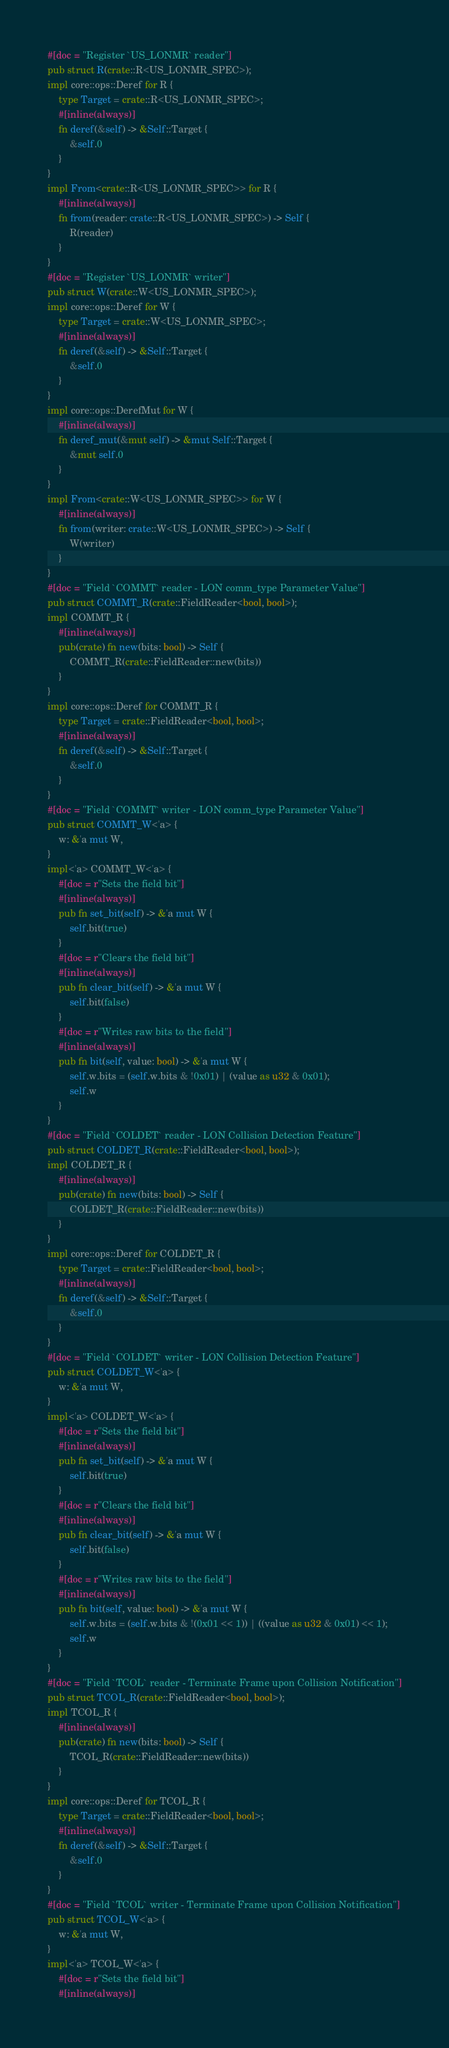Convert code to text. <code><loc_0><loc_0><loc_500><loc_500><_Rust_>#[doc = "Register `US_LONMR` reader"]
pub struct R(crate::R<US_LONMR_SPEC>);
impl core::ops::Deref for R {
    type Target = crate::R<US_LONMR_SPEC>;
    #[inline(always)]
    fn deref(&self) -> &Self::Target {
        &self.0
    }
}
impl From<crate::R<US_LONMR_SPEC>> for R {
    #[inline(always)]
    fn from(reader: crate::R<US_LONMR_SPEC>) -> Self {
        R(reader)
    }
}
#[doc = "Register `US_LONMR` writer"]
pub struct W(crate::W<US_LONMR_SPEC>);
impl core::ops::Deref for W {
    type Target = crate::W<US_LONMR_SPEC>;
    #[inline(always)]
    fn deref(&self) -> &Self::Target {
        &self.0
    }
}
impl core::ops::DerefMut for W {
    #[inline(always)]
    fn deref_mut(&mut self) -> &mut Self::Target {
        &mut self.0
    }
}
impl From<crate::W<US_LONMR_SPEC>> for W {
    #[inline(always)]
    fn from(writer: crate::W<US_LONMR_SPEC>) -> Self {
        W(writer)
    }
}
#[doc = "Field `COMMT` reader - LON comm_type Parameter Value"]
pub struct COMMT_R(crate::FieldReader<bool, bool>);
impl COMMT_R {
    #[inline(always)]
    pub(crate) fn new(bits: bool) -> Self {
        COMMT_R(crate::FieldReader::new(bits))
    }
}
impl core::ops::Deref for COMMT_R {
    type Target = crate::FieldReader<bool, bool>;
    #[inline(always)]
    fn deref(&self) -> &Self::Target {
        &self.0
    }
}
#[doc = "Field `COMMT` writer - LON comm_type Parameter Value"]
pub struct COMMT_W<'a> {
    w: &'a mut W,
}
impl<'a> COMMT_W<'a> {
    #[doc = r"Sets the field bit"]
    #[inline(always)]
    pub fn set_bit(self) -> &'a mut W {
        self.bit(true)
    }
    #[doc = r"Clears the field bit"]
    #[inline(always)]
    pub fn clear_bit(self) -> &'a mut W {
        self.bit(false)
    }
    #[doc = r"Writes raw bits to the field"]
    #[inline(always)]
    pub fn bit(self, value: bool) -> &'a mut W {
        self.w.bits = (self.w.bits & !0x01) | (value as u32 & 0x01);
        self.w
    }
}
#[doc = "Field `COLDET` reader - LON Collision Detection Feature"]
pub struct COLDET_R(crate::FieldReader<bool, bool>);
impl COLDET_R {
    #[inline(always)]
    pub(crate) fn new(bits: bool) -> Self {
        COLDET_R(crate::FieldReader::new(bits))
    }
}
impl core::ops::Deref for COLDET_R {
    type Target = crate::FieldReader<bool, bool>;
    #[inline(always)]
    fn deref(&self) -> &Self::Target {
        &self.0
    }
}
#[doc = "Field `COLDET` writer - LON Collision Detection Feature"]
pub struct COLDET_W<'a> {
    w: &'a mut W,
}
impl<'a> COLDET_W<'a> {
    #[doc = r"Sets the field bit"]
    #[inline(always)]
    pub fn set_bit(self) -> &'a mut W {
        self.bit(true)
    }
    #[doc = r"Clears the field bit"]
    #[inline(always)]
    pub fn clear_bit(self) -> &'a mut W {
        self.bit(false)
    }
    #[doc = r"Writes raw bits to the field"]
    #[inline(always)]
    pub fn bit(self, value: bool) -> &'a mut W {
        self.w.bits = (self.w.bits & !(0x01 << 1)) | ((value as u32 & 0x01) << 1);
        self.w
    }
}
#[doc = "Field `TCOL` reader - Terminate Frame upon Collision Notification"]
pub struct TCOL_R(crate::FieldReader<bool, bool>);
impl TCOL_R {
    #[inline(always)]
    pub(crate) fn new(bits: bool) -> Self {
        TCOL_R(crate::FieldReader::new(bits))
    }
}
impl core::ops::Deref for TCOL_R {
    type Target = crate::FieldReader<bool, bool>;
    #[inline(always)]
    fn deref(&self) -> &Self::Target {
        &self.0
    }
}
#[doc = "Field `TCOL` writer - Terminate Frame upon Collision Notification"]
pub struct TCOL_W<'a> {
    w: &'a mut W,
}
impl<'a> TCOL_W<'a> {
    #[doc = r"Sets the field bit"]
    #[inline(always)]</code> 